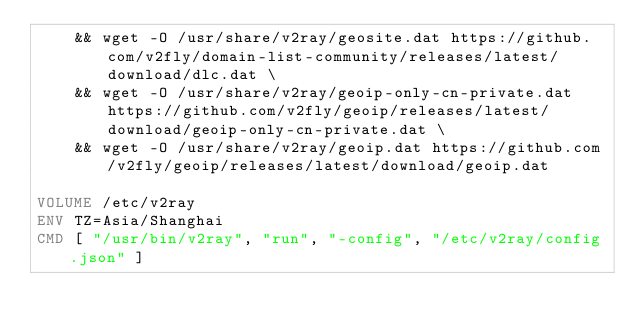<code> <loc_0><loc_0><loc_500><loc_500><_Dockerfile_>	&& wget -O /usr/share/v2ray/geosite.dat https://github.com/v2fly/domain-list-community/releases/latest/download/dlc.dat \
	&& wget -O /usr/share/v2ray/geoip-only-cn-private.dat https://github.com/v2fly/geoip/releases/latest/download/geoip-only-cn-private.dat \
	&& wget -O /usr/share/v2ray/geoip.dat https://github.com/v2fly/geoip/releases/latest/download/geoip.dat

VOLUME /etc/v2ray
ENV TZ=Asia/Shanghai
CMD [ "/usr/bin/v2ray", "run", "-config", "/etc/v2ray/config.json" ]
</code> 